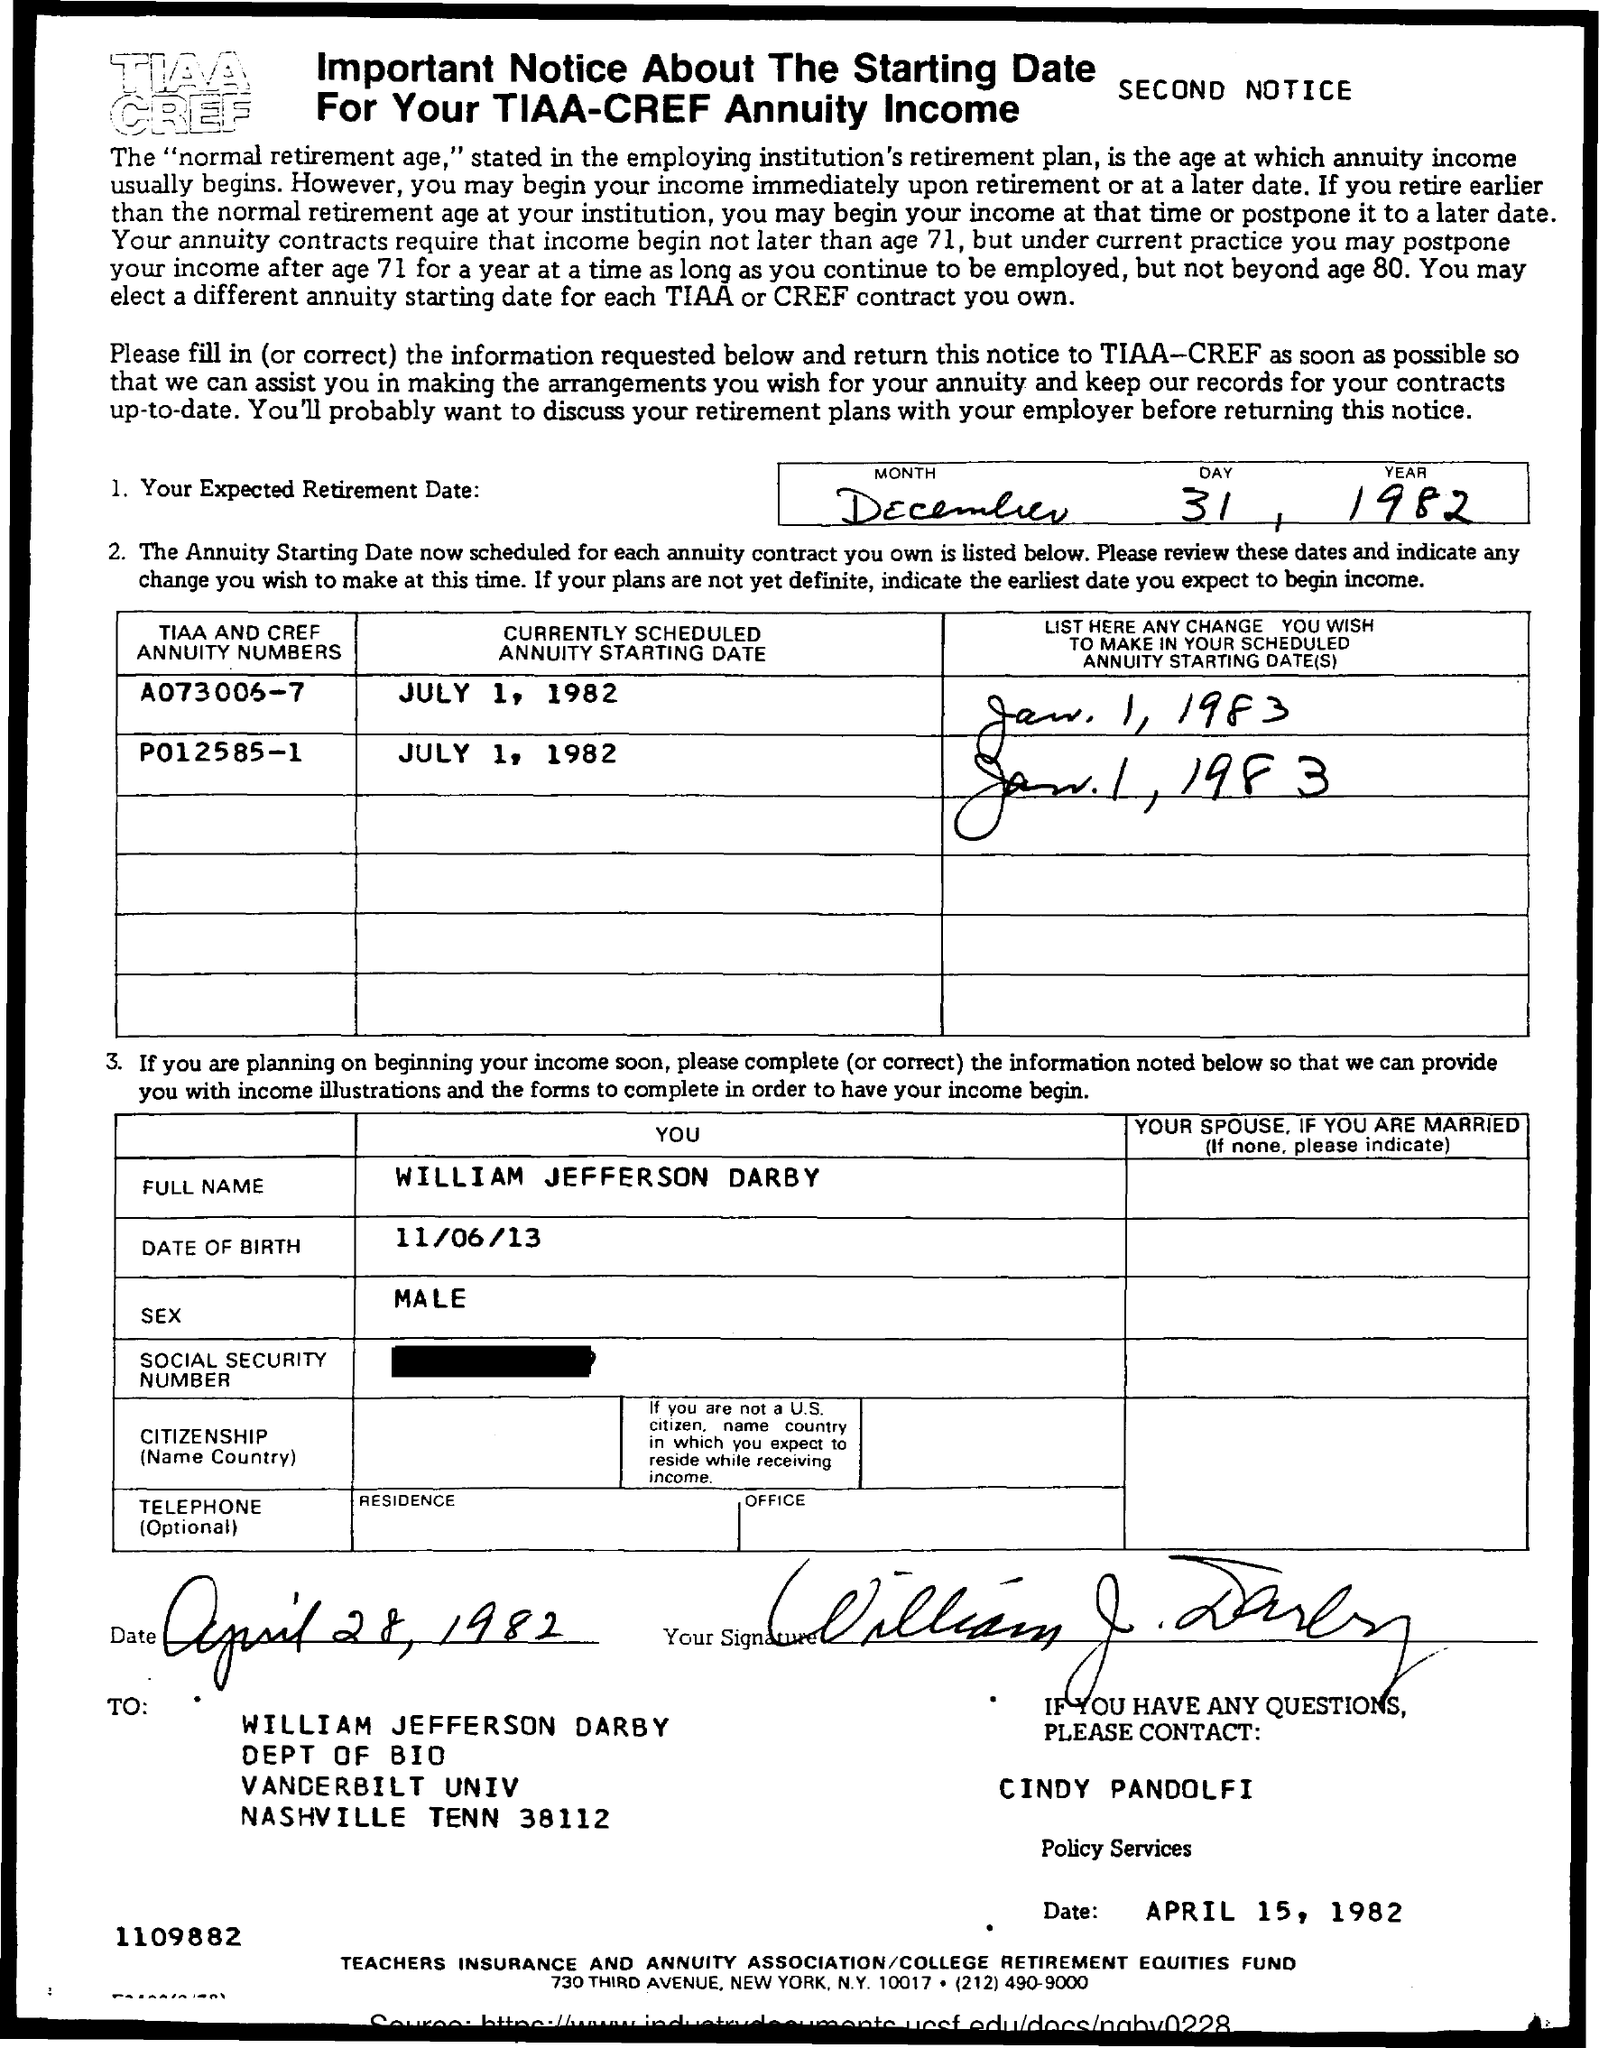List a handful of essential elements in this visual. The date of birth mentioned is June 11, 2013. The date mentioned at the bottom of the page is April 15, 1982. The full name mentioned is William Jefferson Darby. The letter was sent to William Jefferson Darby. What is the sex mentioned? It is male. 